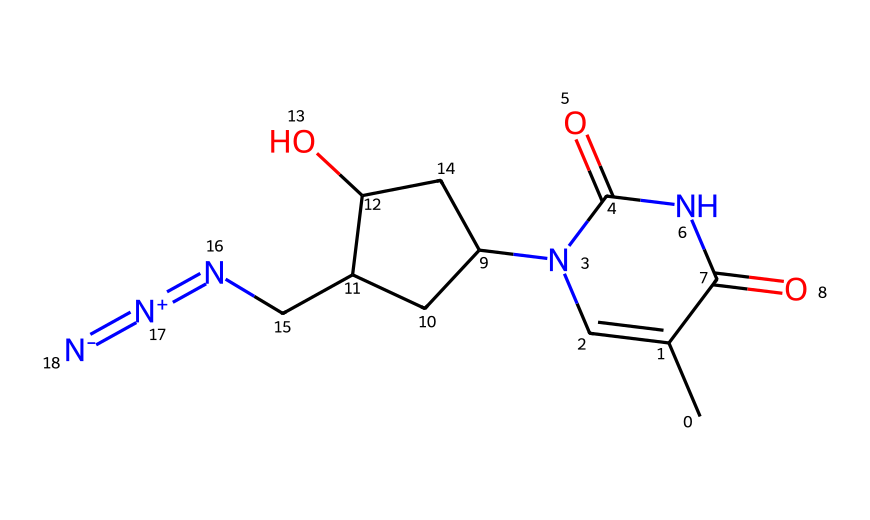What is the molecular formula of azidothymidine? To determine the molecular formula, we analyze the SMILES notation for the composition of the atoms. The key visible atom symbols include C (carbon), N (nitrogen), O (oxygen), and H (hydrogen). Counting each atom gives us C10, H13, N5, O3, leading to the formula C10H13N5O3.
Answer: C10H13N5O3 How many nitrogen atoms are present in the chemical structure? Looking at the SMILES representation, we can identify the nitrogen atoms by counting the occurrences of 'N'. In this structure, there are five nitrogen atoms.
Answer: 5 What kind of functional group is indicated by '=[N+]=[N-]' in the structure? The notation '=[N+]=[N-]' indicates the presence of an azide functional group. This structure features a nitrogen that bears a positive charge and is double-bonded to another nitrogen, which carries a negative charge, characteristic of azides.
Answer: azide How many rings are present in azidothymidine? The rings can be identified in the structure by observing the cyclic components. In this case, there are two rings present in the molecule, as indicated by the numbers in the SMILES.
Answer: 2 What is the significance of the azide group in azidothymidine? The azide group is significant because it contributes to the biological activity of azidothymidine, which is used as an antiviral medication. The presence of this group impacts the interactions with biological targets, particularly in inhibiting viral replication.
Answer: antiviral activity 